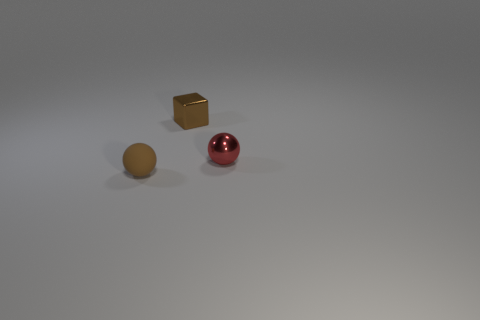Add 2 small brown matte spheres. How many objects exist? 5 Subtract all spheres. How many objects are left? 1 Add 3 large gray shiny cylinders. How many large gray shiny cylinders exist? 3 Subtract 1 red spheres. How many objects are left? 2 Subtract all brown matte things. Subtract all red spheres. How many objects are left? 1 Add 3 small matte things. How many small matte things are left? 4 